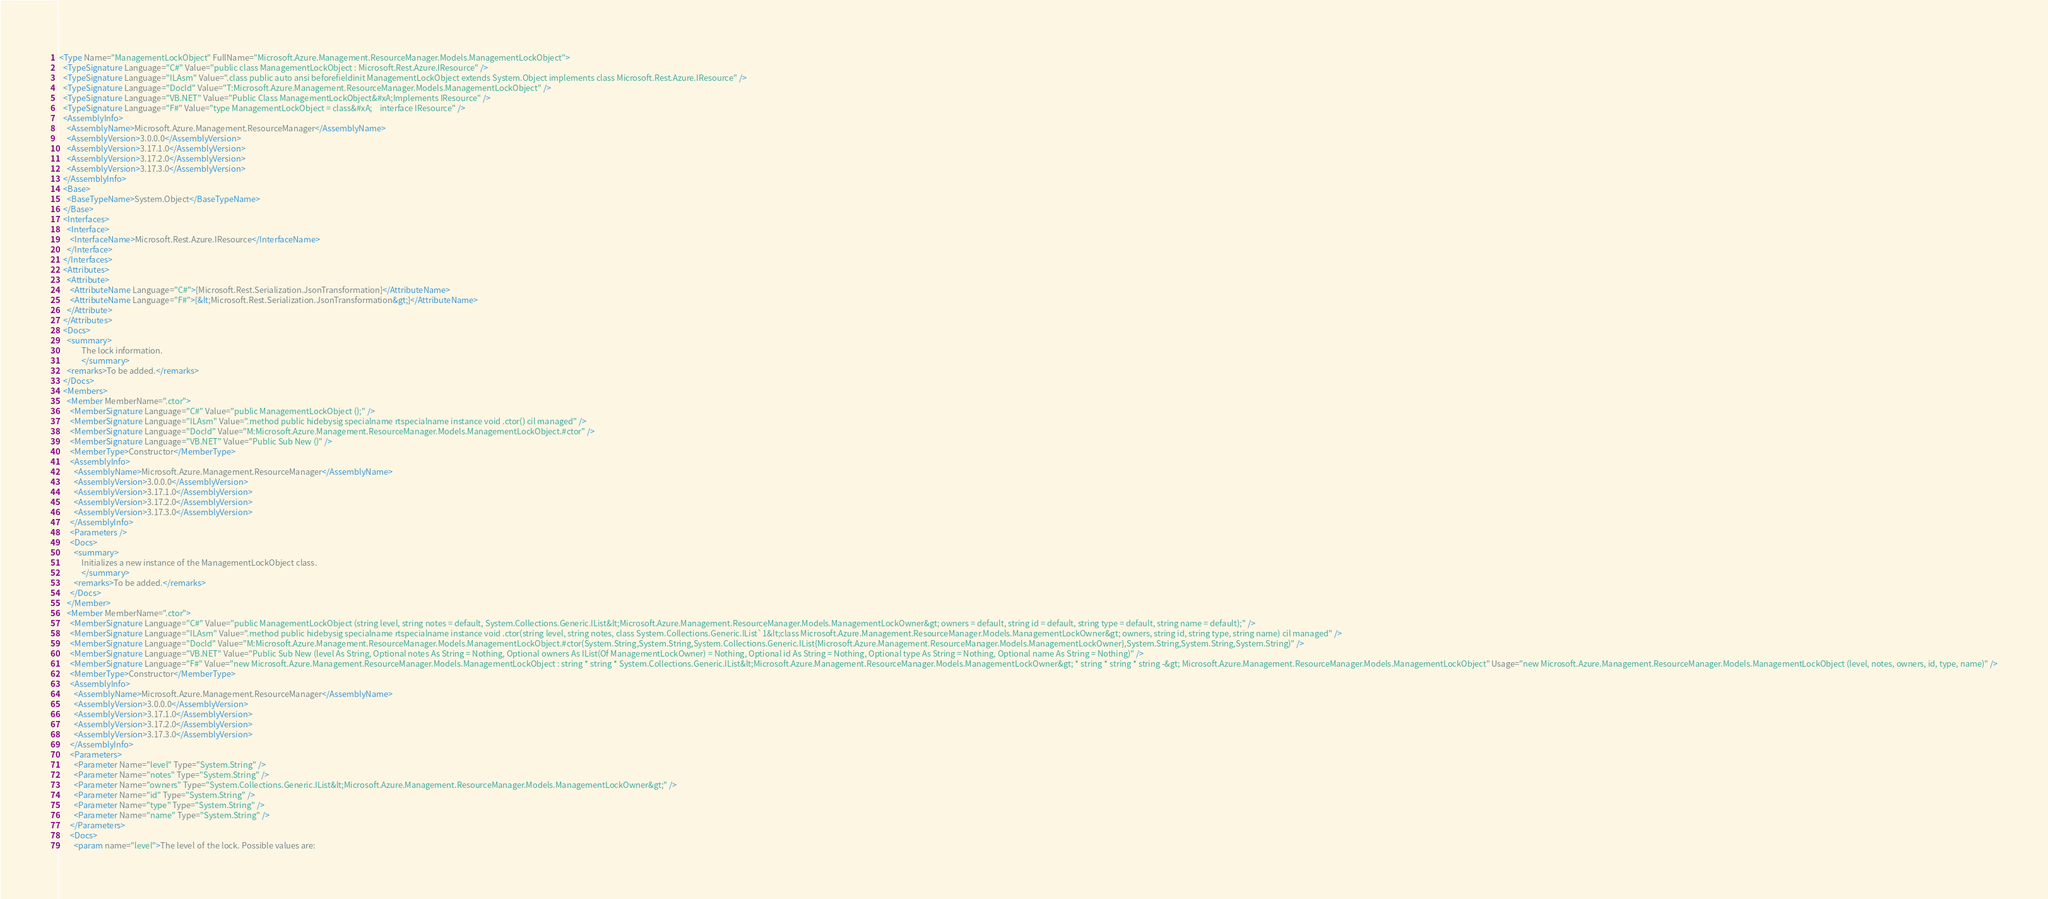<code> <loc_0><loc_0><loc_500><loc_500><_XML_><Type Name="ManagementLockObject" FullName="Microsoft.Azure.Management.ResourceManager.Models.ManagementLockObject">
  <TypeSignature Language="C#" Value="public class ManagementLockObject : Microsoft.Rest.Azure.IResource" />
  <TypeSignature Language="ILAsm" Value=".class public auto ansi beforefieldinit ManagementLockObject extends System.Object implements class Microsoft.Rest.Azure.IResource" />
  <TypeSignature Language="DocId" Value="T:Microsoft.Azure.Management.ResourceManager.Models.ManagementLockObject" />
  <TypeSignature Language="VB.NET" Value="Public Class ManagementLockObject&#xA;Implements IResource" />
  <TypeSignature Language="F#" Value="type ManagementLockObject = class&#xA;    interface IResource" />
  <AssemblyInfo>
    <AssemblyName>Microsoft.Azure.Management.ResourceManager</AssemblyName>
    <AssemblyVersion>3.0.0.0</AssemblyVersion>
    <AssemblyVersion>3.17.1.0</AssemblyVersion>
    <AssemblyVersion>3.17.2.0</AssemblyVersion>
    <AssemblyVersion>3.17.3.0</AssemblyVersion>
  </AssemblyInfo>
  <Base>
    <BaseTypeName>System.Object</BaseTypeName>
  </Base>
  <Interfaces>
    <Interface>
      <InterfaceName>Microsoft.Rest.Azure.IResource</InterfaceName>
    </Interface>
  </Interfaces>
  <Attributes>
    <Attribute>
      <AttributeName Language="C#">[Microsoft.Rest.Serialization.JsonTransformation]</AttributeName>
      <AttributeName Language="F#">[&lt;Microsoft.Rest.Serialization.JsonTransformation&gt;]</AttributeName>
    </Attribute>
  </Attributes>
  <Docs>
    <summary>
            The lock information.
            </summary>
    <remarks>To be added.</remarks>
  </Docs>
  <Members>
    <Member MemberName=".ctor">
      <MemberSignature Language="C#" Value="public ManagementLockObject ();" />
      <MemberSignature Language="ILAsm" Value=".method public hidebysig specialname rtspecialname instance void .ctor() cil managed" />
      <MemberSignature Language="DocId" Value="M:Microsoft.Azure.Management.ResourceManager.Models.ManagementLockObject.#ctor" />
      <MemberSignature Language="VB.NET" Value="Public Sub New ()" />
      <MemberType>Constructor</MemberType>
      <AssemblyInfo>
        <AssemblyName>Microsoft.Azure.Management.ResourceManager</AssemblyName>
        <AssemblyVersion>3.0.0.0</AssemblyVersion>
        <AssemblyVersion>3.17.1.0</AssemblyVersion>
        <AssemblyVersion>3.17.2.0</AssemblyVersion>
        <AssemblyVersion>3.17.3.0</AssemblyVersion>
      </AssemblyInfo>
      <Parameters />
      <Docs>
        <summary>
            Initializes a new instance of the ManagementLockObject class.
            </summary>
        <remarks>To be added.</remarks>
      </Docs>
    </Member>
    <Member MemberName=".ctor">
      <MemberSignature Language="C#" Value="public ManagementLockObject (string level, string notes = default, System.Collections.Generic.IList&lt;Microsoft.Azure.Management.ResourceManager.Models.ManagementLockOwner&gt; owners = default, string id = default, string type = default, string name = default);" />
      <MemberSignature Language="ILAsm" Value=".method public hidebysig specialname rtspecialname instance void .ctor(string level, string notes, class System.Collections.Generic.IList`1&lt;class Microsoft.Azure.Management.ResourceManager.Models.ManagementLockOwner&gt; owners, string id, string type, string name) cil managed" />
      <MemberSignature Language="DocId" Value="M:Microsoft.Azure.Management.ResourceManager.Models.ManagementLockObject.#ctor(System.String,System.String,System.Collections.Generic.IList{Microsoft.Azure.Management.ResourceManager.Models.ManagementLockOwner},System.String,System.String,System.String)" />
      <MemberSignature Language="VB.NET" Value="Public Sub New (level As String, Optional notes As String = Nothing, Optional owners As IList(Of ManagementLockOwner) = Nothing, Optional id As String = Nothing, Optional type As String = Nothing, Optional name As String = Nothing)" />
      <MemberSignature Language="F#" Value="new Microsoft.Azure.Management.ResourceManager.Models.ManagementLockObject : string * string * System.Collections.Generic.IList&lt;Microsoft.Azure.Management.ResourceManager.Models.ManagementLockOwner&gt; * string * string * string -&gt; Microsoft.Azure.Management.ResourceManager.Models.ManagementLockObject" Usage="new Microsoft.Azure.Management.ResourceManager.Models.ManagementLockObject (level, notes, owners, id, type, name)" />
      <MemberType>Constructor</MemberType>
      <AssemblyInfo>
        <AssemblyName>Microsoft.Azure.Management.ResourceManager</AssemblyName>
        <AssemblyVersion>3.0.0.0</AssemblyVersion>
        <AssemblyVersion>3.17.1.0</AssemblyVersion>
        <AssemblyVersion>3.17.2.0</AssemblyVersion>
        <AssemblyVersion>3.17.3.0</AssemblyVersion>
      </AssemblyInfo>
      <Parameters>
        <Parameter Name="level" Type="System.String" />
        <Parameter Name="notes" Type="System.String" />
        <Parameter Name="owners" Type="System.Collections.Generic.IList&lt;Microsoft.Azure.Management.ResourceManager.Models.ManagementLockOwner&gt;" />
        <Parameter Name="id" Type="System.String" />
        <Parameter Name="type" Type="System.String" />
        <Parameter Name="name" Type="System.String" />
      </Parameters>
      <Docs>
        <param name="level">The level of the lock. Possible values are:</code> 